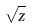Convert formula to latex. <formula><loc_0><loc_0><loc_500><loc_500>\sqrt { z }</formula> 